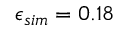<formula> <loc_0><loc_0><loc_500><loc_500>\epsilon _ { s i m } = 0 . 1 8</formula> 